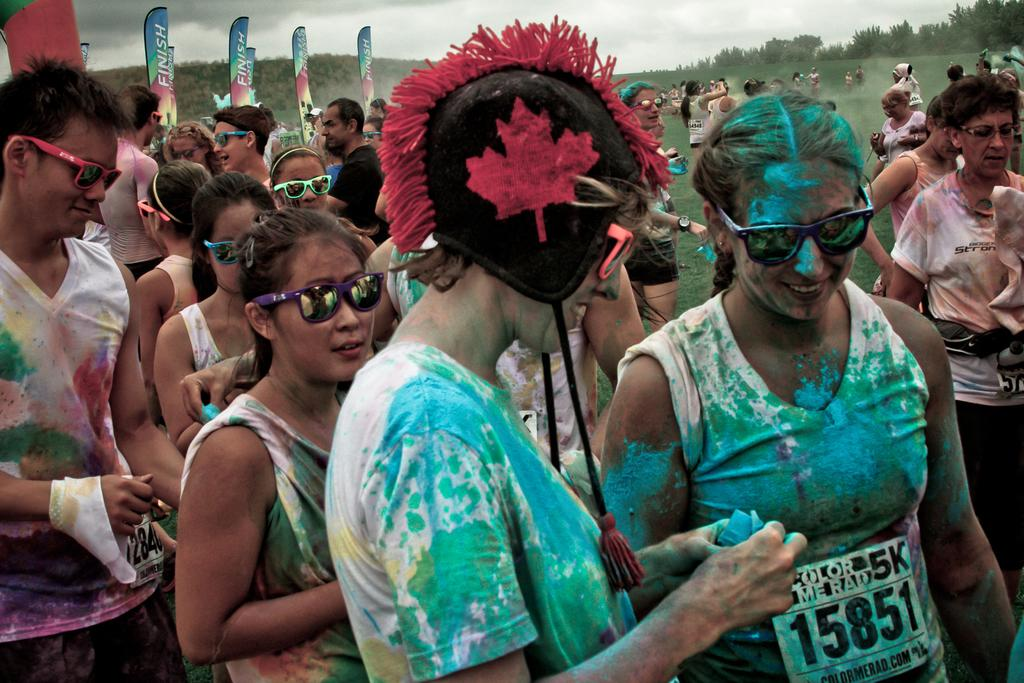What is happening in the center of the image? There are people standing in the center of the image. What are the people wearing? The people are dressed in costumes. What can be seen in the background of the image? There are flags and trees in the background of the image, as well as the sky. How much was the payment for the camera used to take this image? There is no information about a camera or payment in the image or the provided facts. 